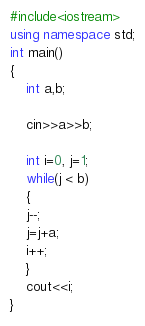<code> <loc_0><loc_0><loc_500><loc_500><_C++_>#include<iostream>
using namespace std;
int main()
{
	int a,b;
	
	cin>>a>>b;
	
	int i=0, j=1;
	while(j < b)
	{
	j--;
	j=j+a;
	i++;
	}
	cout<<i;
}</code> 